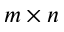<formula> <loc_0><loc_0><loc_500><loc_500>m \times n</formula> 